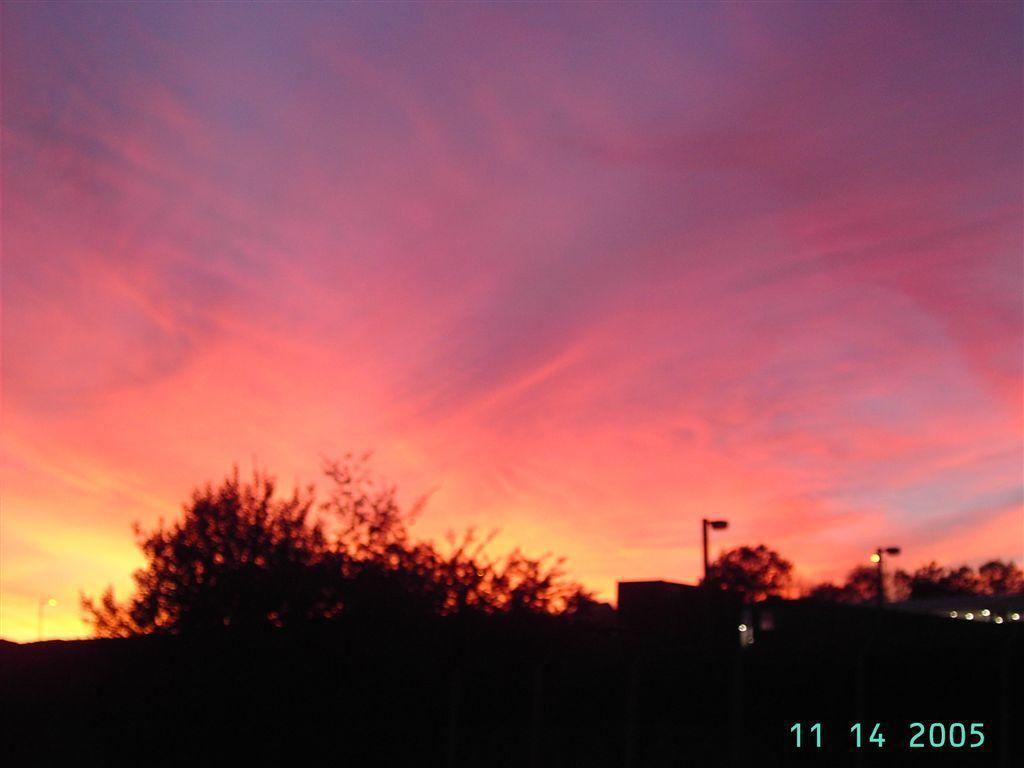How would you summarize this image in a sentence or two? In this image, there are some trees, at the right side there two street lights, at the top there is a sky, at the right side bottom corner there are some numbers like 11 14 2005. 